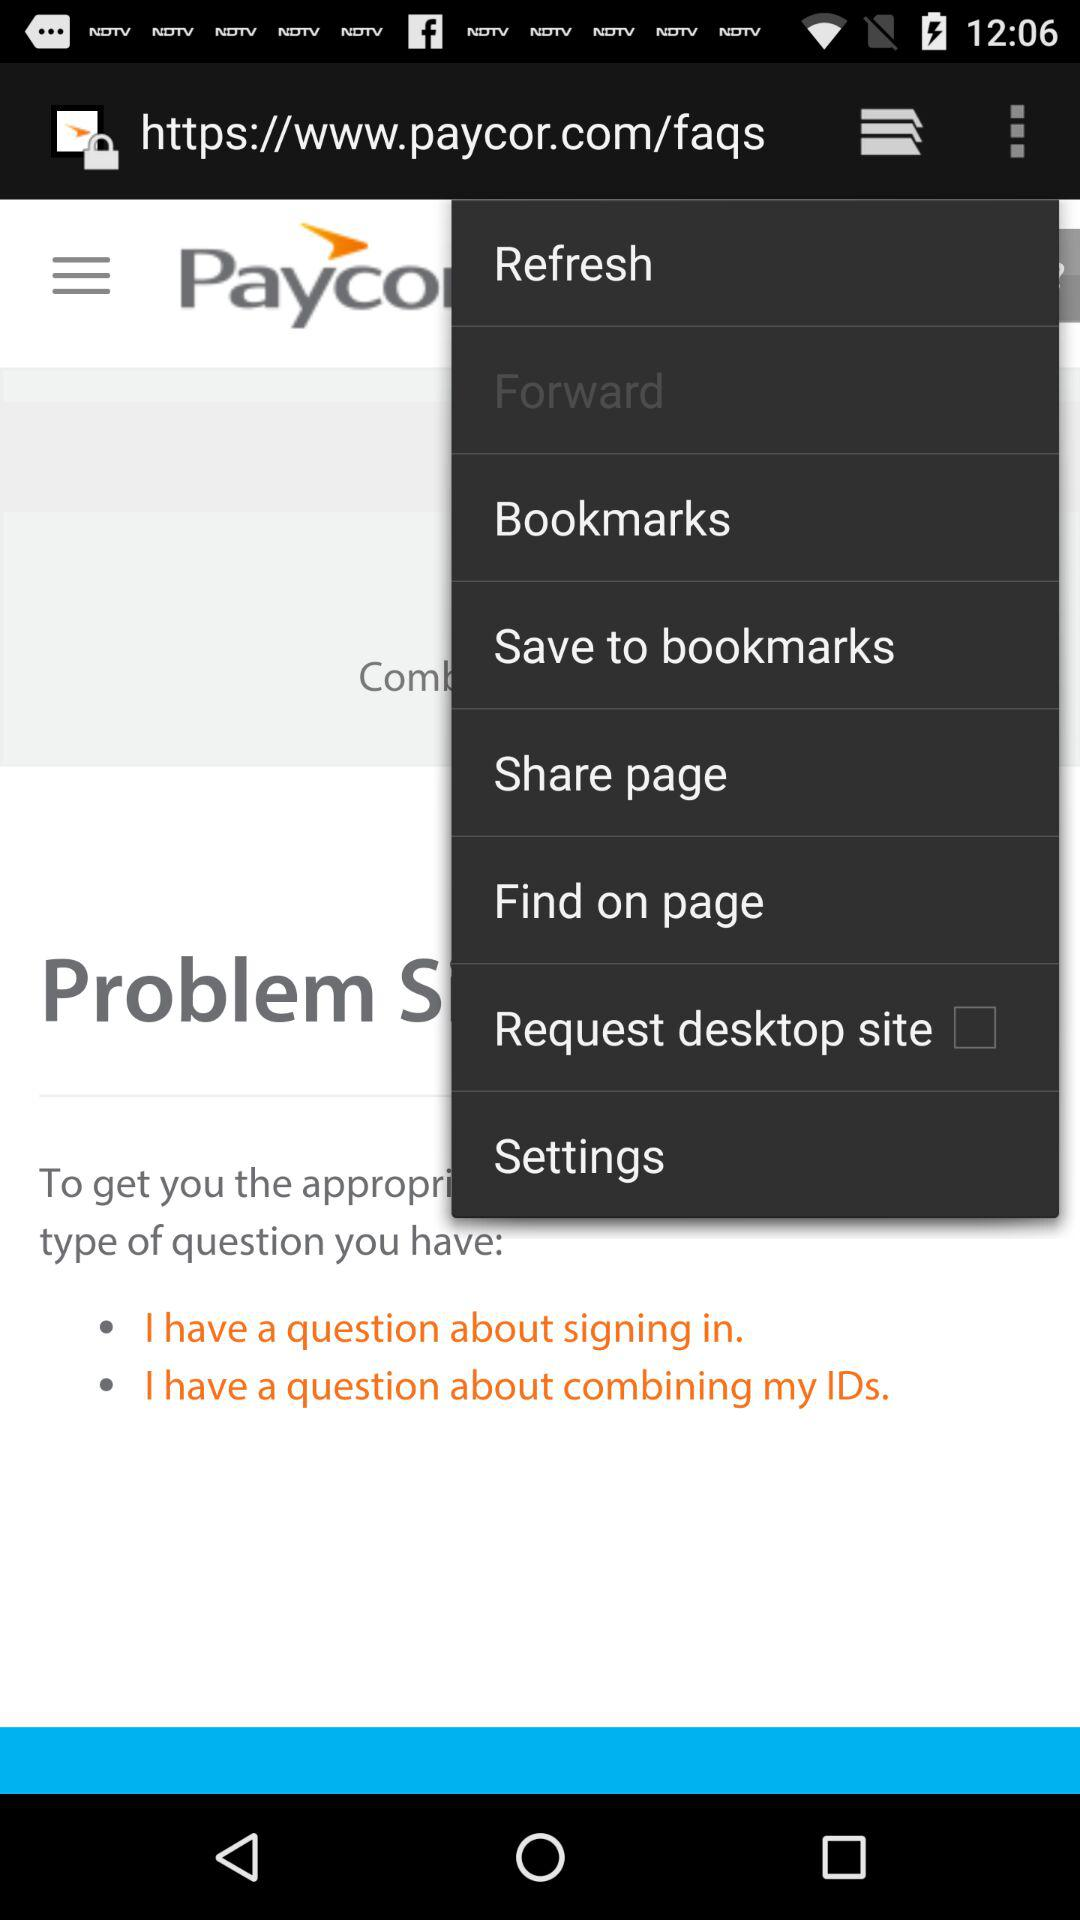How many gray circles are there on the screen?
Answer the question using a single word or phrase. 2 